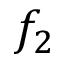Convert formula to latex. <formula><loc_0><loc_0><loc_500><loc_500>f _ { 2 }</formula> 